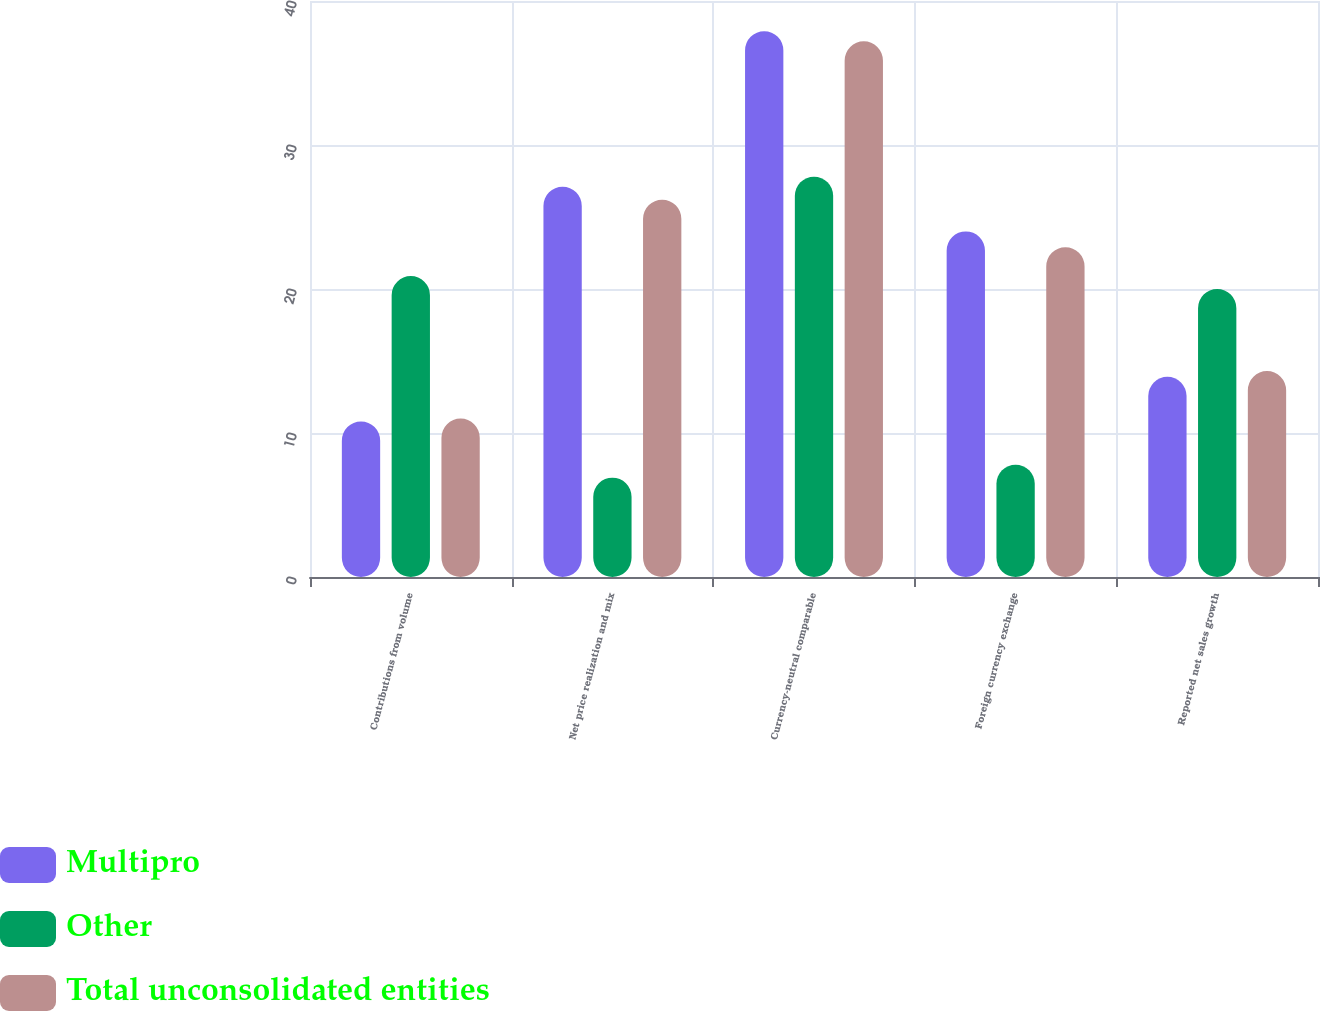Convert chart to OTSL. <chart><loc_0><loc_0><loc_500><loc_500><stacked_bar_chart><ecel><fcel>Contributions from volume<fcel>Net price realization and mix<fcel>Currency-neutral comparable<fcel>Foreign currency exchange<fcel>Reported net sales growth<nl><fcel>Multipro<fcel>10.8<fcel>27.1<fcel>37.9<fcel>24<fcel>13.9<nl><fcel>Other<fcel>20.9<fcel>6.9<fcel>27.8<fcel>7.8<fcel>20<nl><fcel>Total unconsolidated entities<fcel>11<fcel>26.2<fcel>37.2<fcel>22.9<fcel>14.3<nl></chart> 